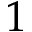<formula> <loc_0><loc_0><loc_500><loc_500>1</formula> 